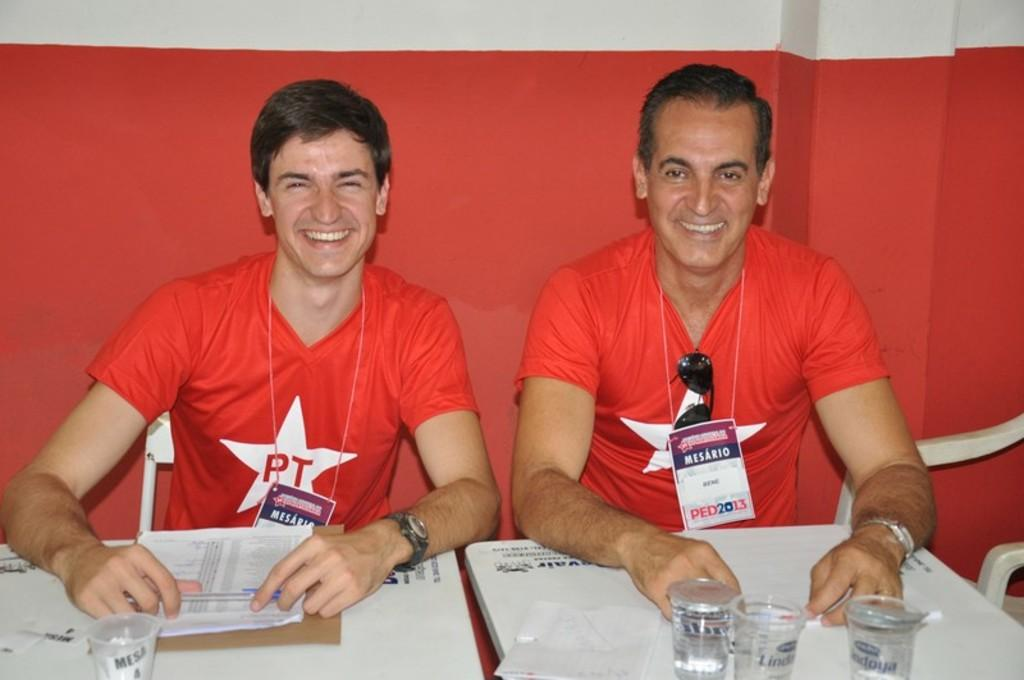<image>
Present a compact description of the photo's key features. Two men wearing shirts that say PT are sitting at a table. 